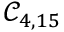<formula> <loc_0><loc_0><loc_500><loc_500>\mathcal { C } _ { 4 , 1 5 }</formula> 